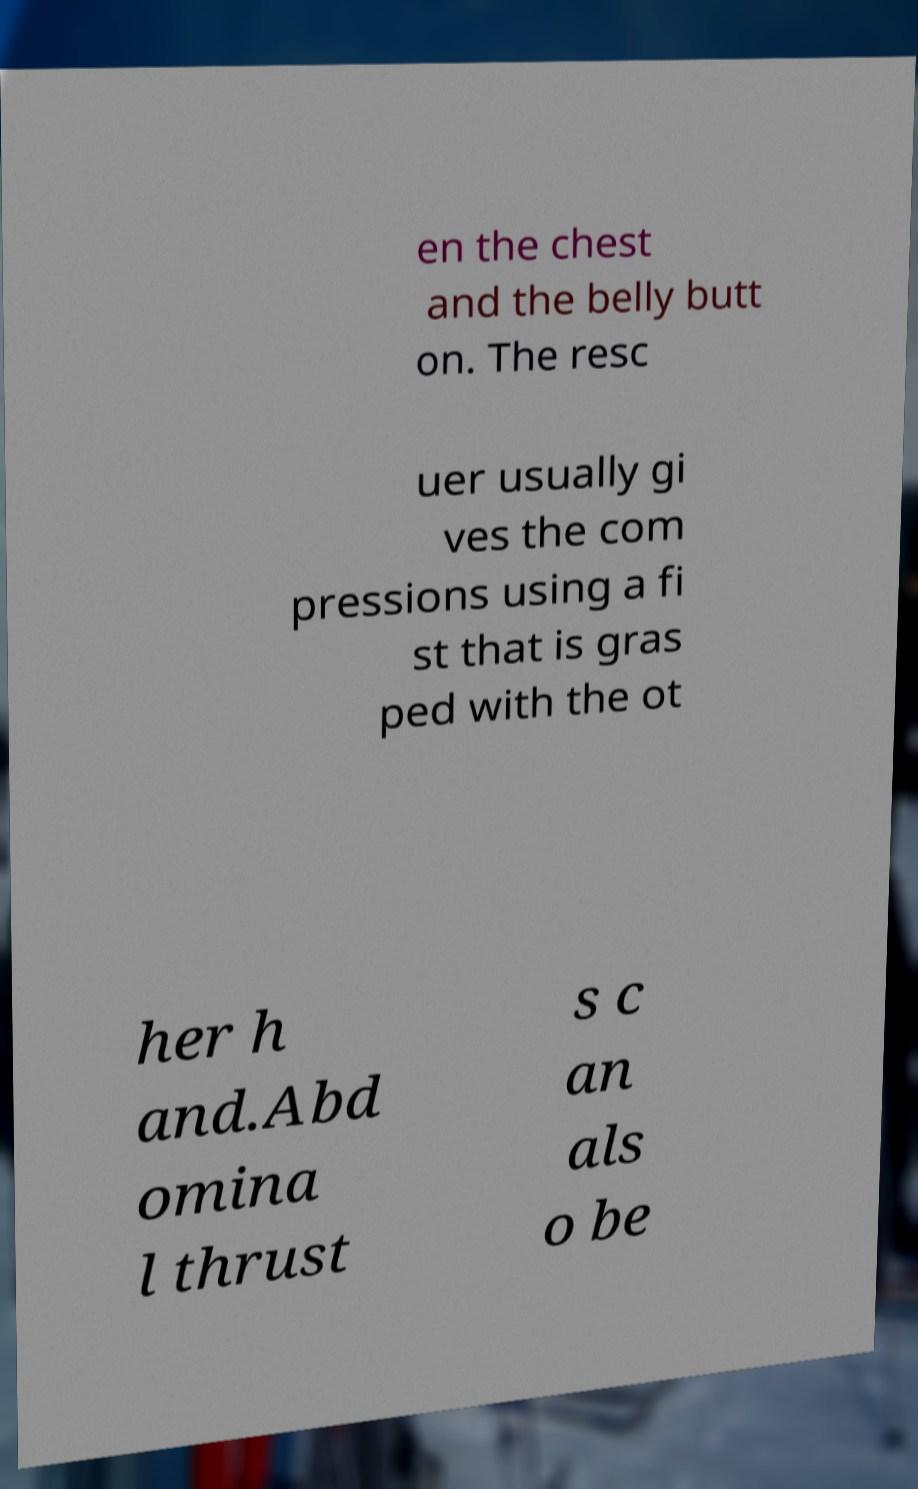Could you extract and type out the text from this image? en the chest and the belly butt on. The resc uer usually gi ves the com pressions using a fi st that is gras ped with the ot her h and.Abd omina l thrust s c an als o be 